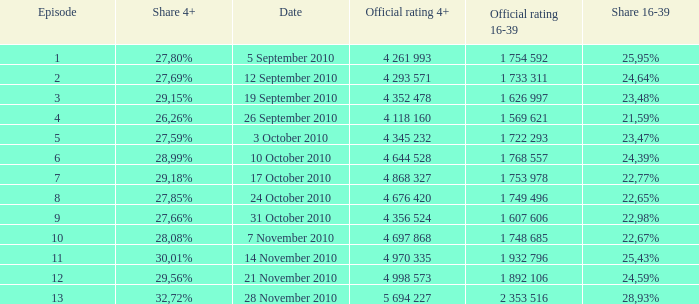What is the official rating 16-39 for the episode with  a 16-39 share of 22,77%? 1 753 978. 